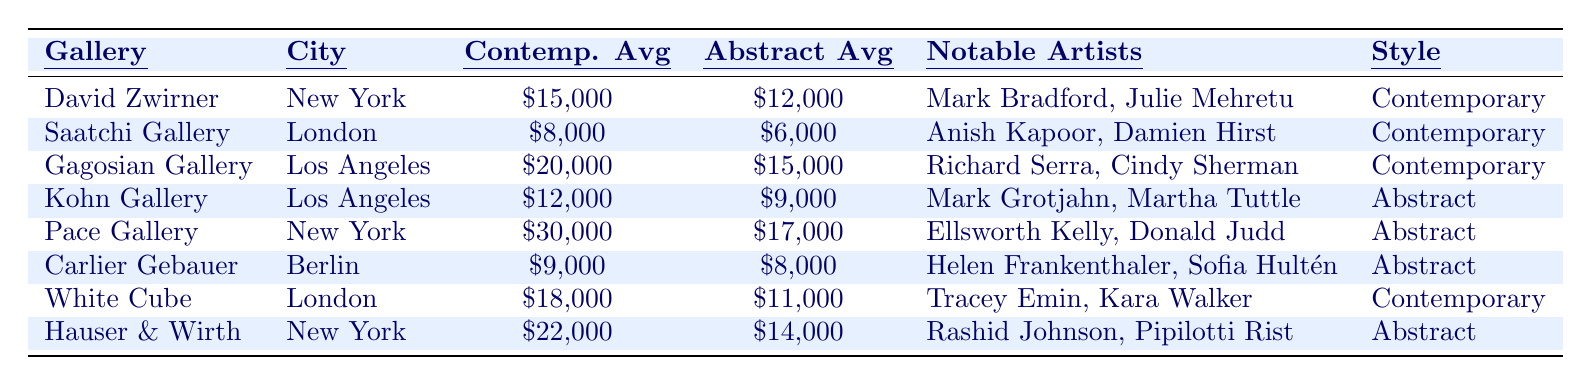What is the average price of contemporary art at David Zwirner? The table shows that the average price of contemporary art at David Zwirner is \$15,000.
Answer: \$15,000 What is the average price of abstract art at Pace Gallery? The table indicates that the average price of abstract art at Pace Gallery is \$17,000.
Answer: \$17,000 Which gallery has the highest average price for contemporary art? According to the table, Pace Gallery has the highest average price for contemporary art at \$30,000.
Answer: Pace Gallery What is the difference in average price between contemporary and abstract art at Gagosian Gallery? For Gagosian Gallery, the average price of contemporary art is \$20,000 and the average price of abstract art is \$15,000. The difference is \$20,000 - \$15,000 = \$5,000.
Answer: \$5,000 Is the average price of abstract art at White Cube greater than that at Carlier Gebauer? The table shows that the average price of abstract art at White Cube is \$11,000, while at Carlier Gebauer it is \$8,000. Since \$11,000 > \$8,000, the statement is true.
Answer: Yes What is the total average price of contemporary art for all galleries listed? The total average price of contemporary art can be calculated by summing the average prices: \$15,000 + \$8,000 + \$20,000 + \$12,000 + \$30,000 + \$18,000 + \$22,000 = \$125,000.
Answer: \$125,000 How many notable artists are mentioned in the Kohn Gallery entry? The table states that Kohn Gallery features two notable artists: Mark Grotjahn and Martha Tuttle.
Answer: 2 Which city has the highest average price of abstract art based on this table? By comparing the average prices of abstract art in New York (\$14,000 from Hauser & Wirth and \$17,000 from Pace) to the other cities: Los Angeles (\$9,000 and \$15,000), London (\$6,000 and \$11,000), and Berlin (\$8,000). The highest is \$17,000 in New York at Pace Gallery.
Answer: New York What is the combined average price of abstract art in London? In London, the average price of abstract art at Saatchi Gallery is \$6,000 and at White Cube is \$11,000. The combined average is (\$6,000 + \$11,000) / 2 = \$8,500.
Answer: \$8,500 Is the average price of contemporary art at Gagosian Gallery above \$15,000? According to the table, the average price of contemporary art at Gagosian Gallery is \$20,000, which is above \$15,000. Thus, the statement is true.
Answer: Yes 